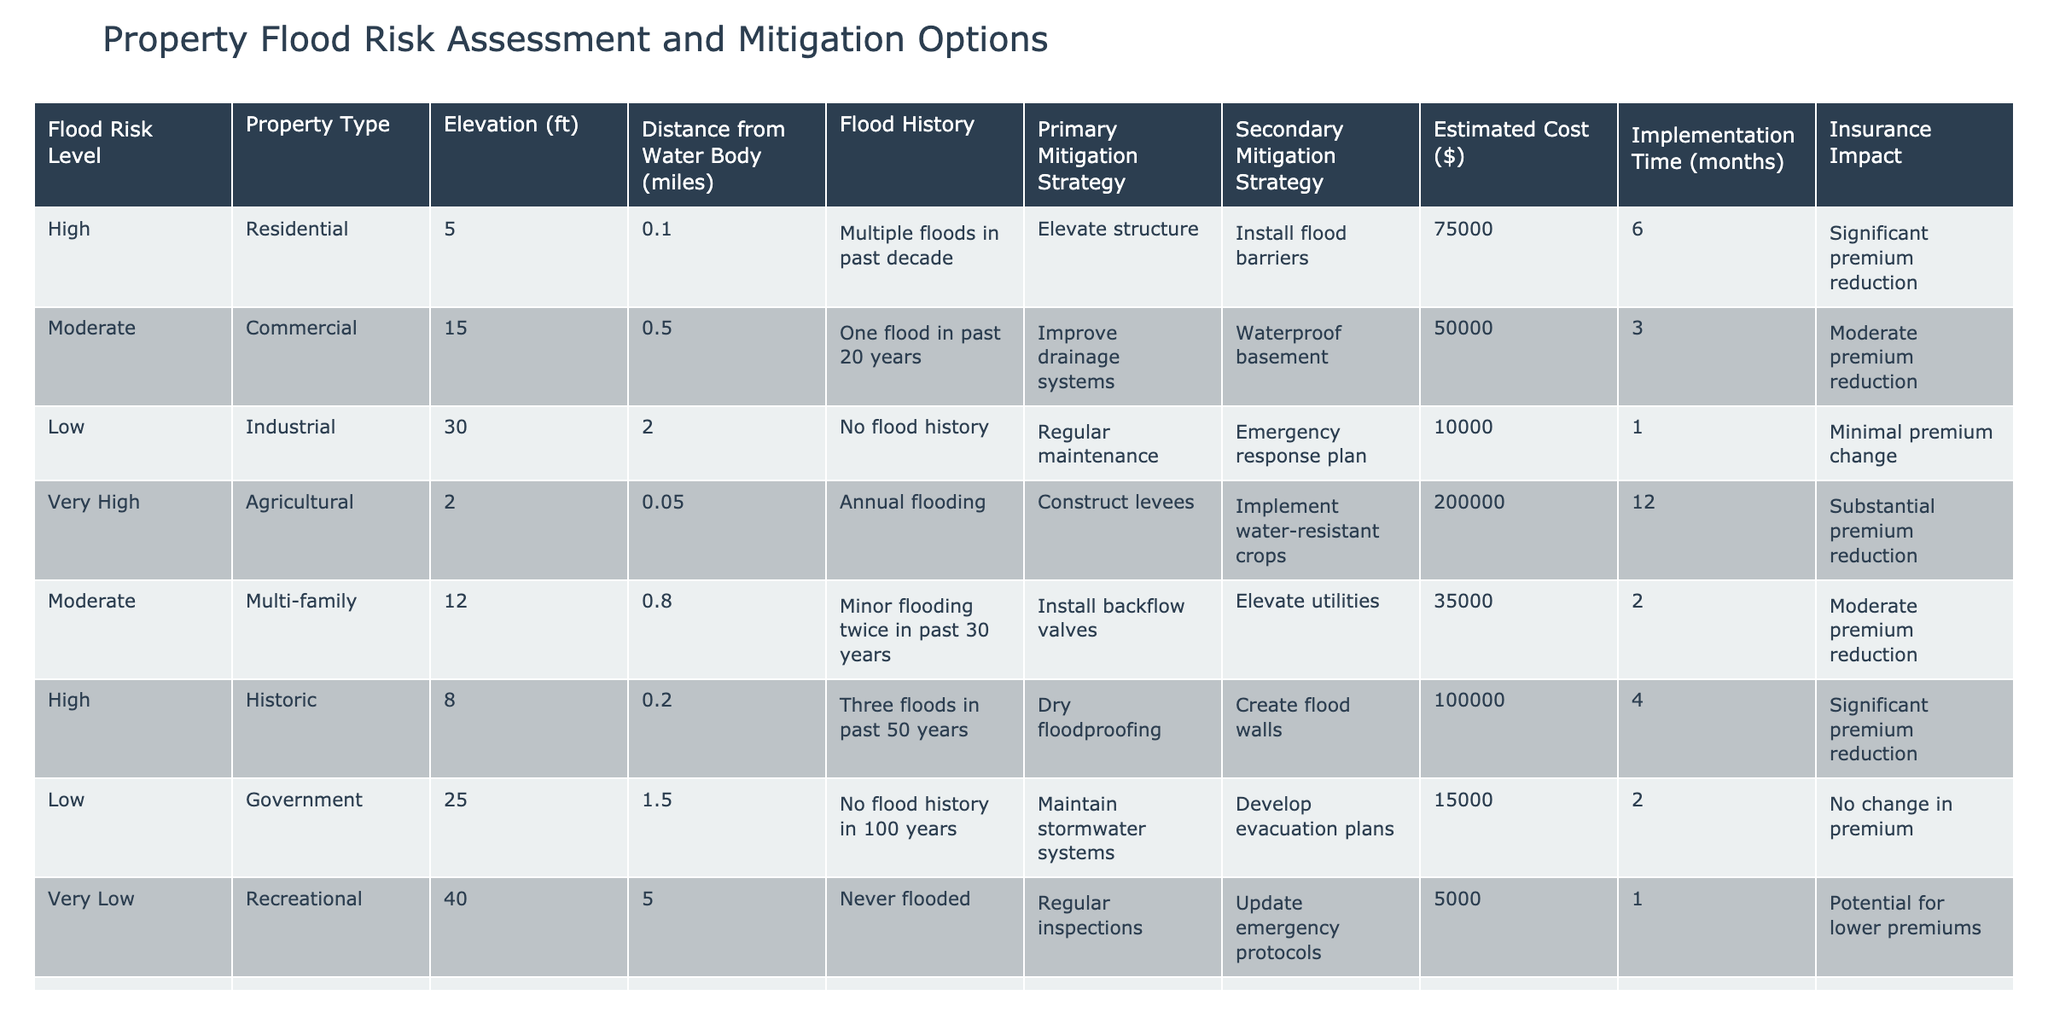What is the estimated cost of implementing mitigation strategies for high flood risk in residential properties? The table indicates that the estimated cost for high flood risk residential properties is $75,000 as stated in the corresponding row.
Answer: 75000 How many months does it take to implement the secondary mitigation strategy for agricultural properties? The table shows that for agricultural properties with a very high flood risk, the implementation time for the secondary strategy (implementing water-resistant crops) is 12 months as indicated in the respective row.
Answer: 12 Is there any property type that has never flooded? Yes, the table shows that recreational properties fall into the very low flood risk category and have never flooded as indicated in the flood history column.
Answer: Yes What is the average implementation time for properties with moderate flood risk? There are three properties with moderate flood risk (commercial, multi-family, and educational). Their implementation times are 3, 2, and 3 months, respectively. The average implementation time is calculated by summing these values (3 + 2 + 3) = 8 and then dividing by 3, resulting in 8/3 = approximately 2.67 months.
Answer: 2.67 Which property type has the highest estimated cost for mitigation strategies? By examining all entries in the estimated cost column, agricultural properties have the highest cost at $200,000, which exceeds the costs of all other types.
Answer: Agricultural What are the primary mitigation strategies for properties with high flood risk? The table lists two high flood risk property types: residential and healthcare. For residential properties, the primary strategy is to elevate the structure, while for healthcare properties, it is wet floodproofing.
Answer: Elevate structure and wet floodproofing If a property has a low flood risk, what mitigation strategies are suggested? According to the table, low flood risk properties are recommended to undergo regular maintenance as the primary strategy and develop evacuation plans as the secondary strategy.
Answer: Regular maintenance and develop evacuation plans Is there any significant insurance premium impact for properties classified as low flood risk? The table notes that for properties with low flood risk (industrial and government), the insurance premium change is minimal for industrial and there is no change for government, indicating limited impact.
Answer: No What is the total estimated cost of mitigation strategies for properties with high flood risk? There are three properties with high flood risk: residential ($75,000), historic ($100,000), and healthcare ($150,000). Summing these costs results in $75,000 + $100,000 + $150,000 = $325,000.
Answer: 325000 